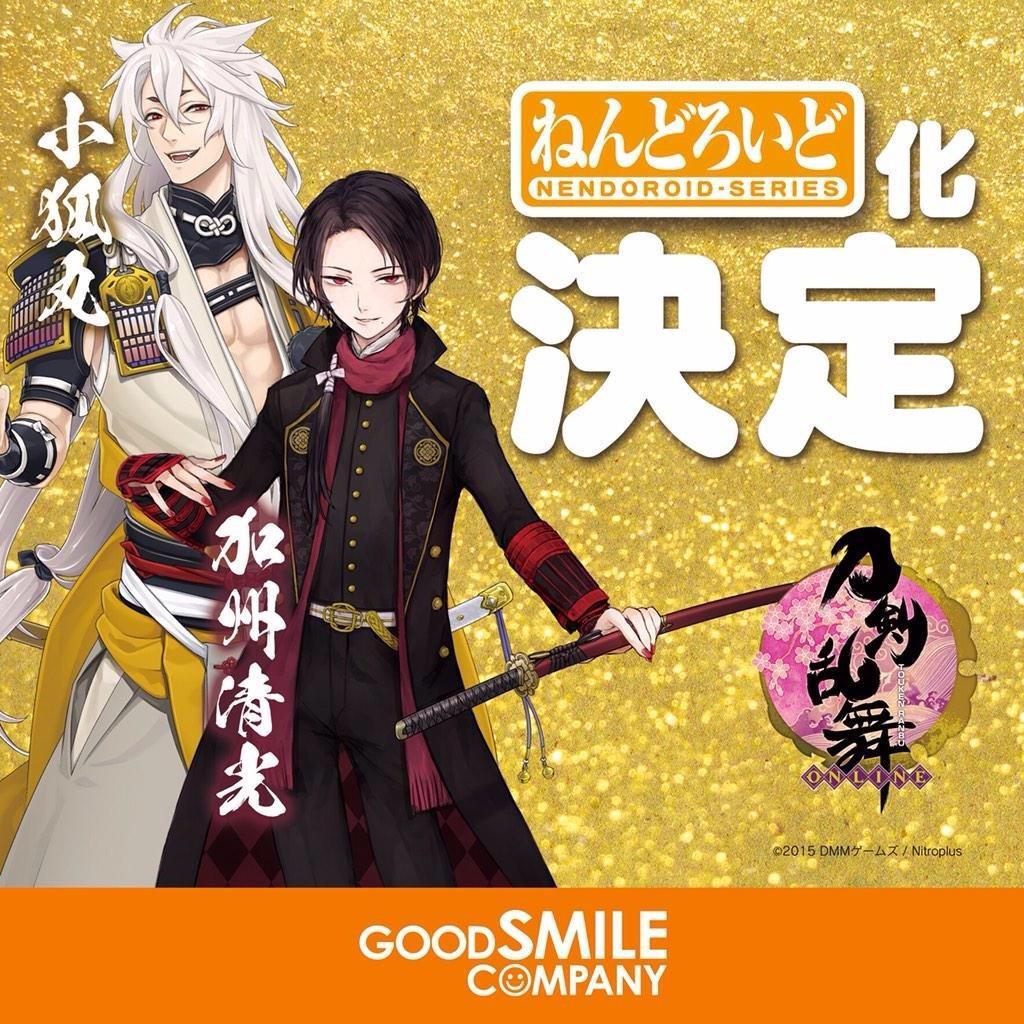Please provide a concise description of this image. In this picture, there are two cartoons towards the left. One of them is wearing black and another is wearing white. Towards the right, there is some text and a symbol. 